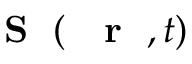<formula> <loc_0><loc_0><loc_500><loc_500>{ S } ( { r } , t )</formula> 